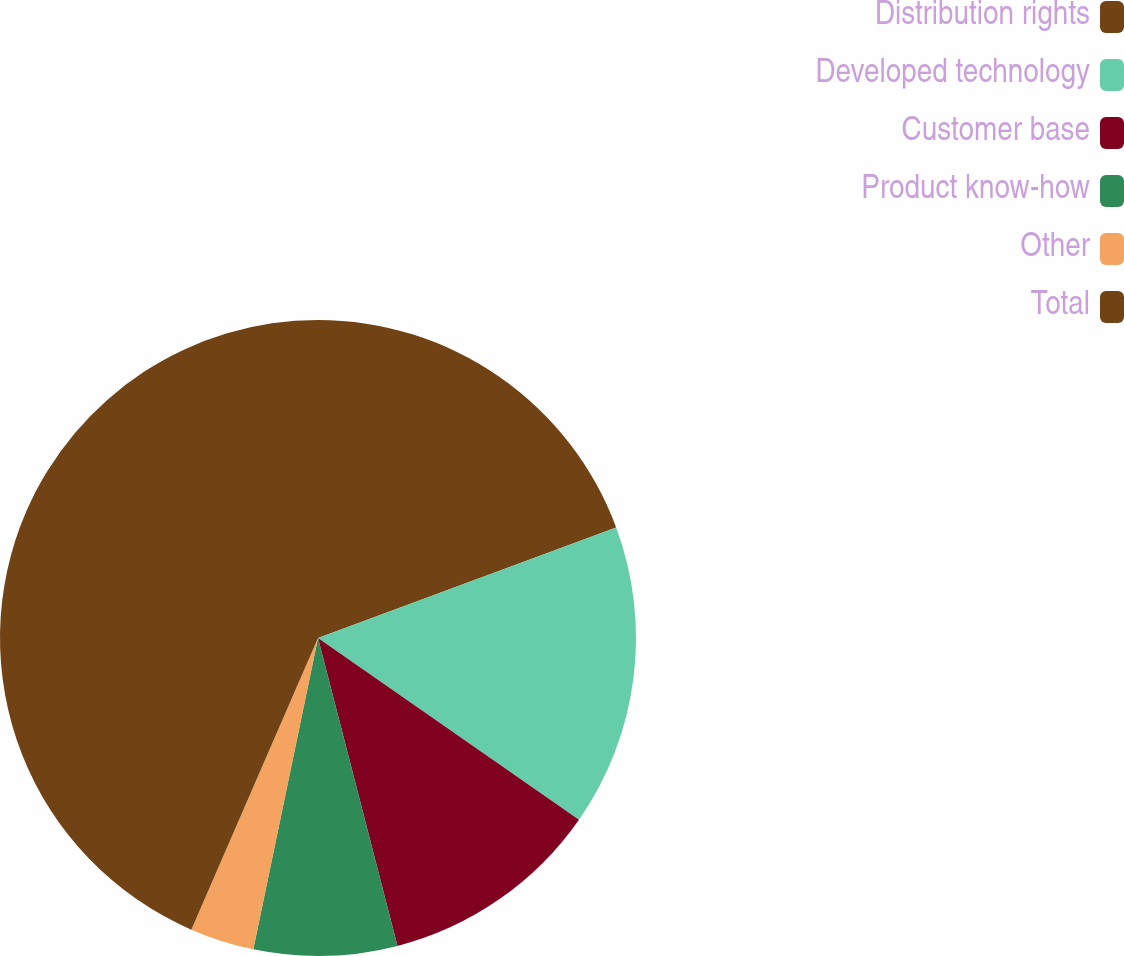Convert chart. <chart><loc_0><loc_0><loc_500><loc_500><pie_chart><fcel>Distribution rights<fcel>Developed technology<fcel>Customer base<fcel>Product know-how<fcel>Other<fcel>Total<nl><fcel>19.35%<fcel>15.33%<fcel>11.3%<fcel>7.28%<fcel>3.26%<fcel>43.48%<nl></chart> 